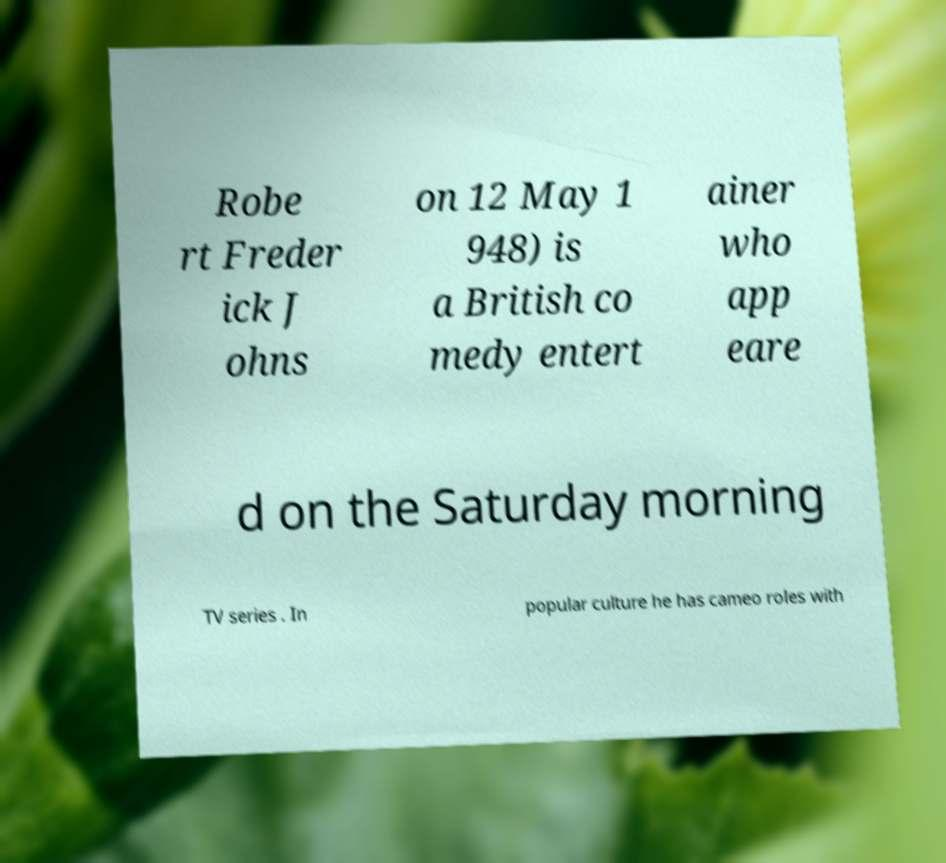Please identify and transcribe the text found in this image. Robe rt Freder ick J ohns on 12 May 1 948) is a British co medy entert ainer who app eare d on the Saturday morning TV series . In popular culture he has cameo roles with 